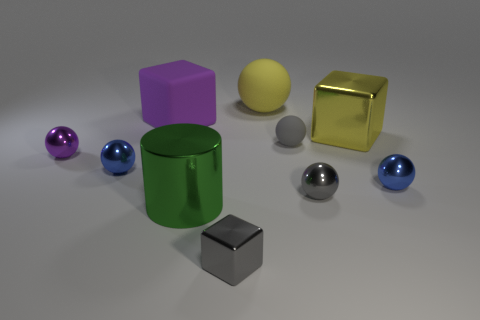Is the number of big matte things in front of the small gray rubber object greater than the number of gray shiny spheres? No, the number of big matte things in front of the small gray rubber object, which appears to be a cube, is not greater than the number of gray shiny spheres. In the image, there are two large matte objects in front of the gray cube – a purple cube and a green cylinder. As for the gray shiny spheres, there are also two in number, positioned away from the small gray cube. So, in this case, the quantities are equal, not greater or less. 